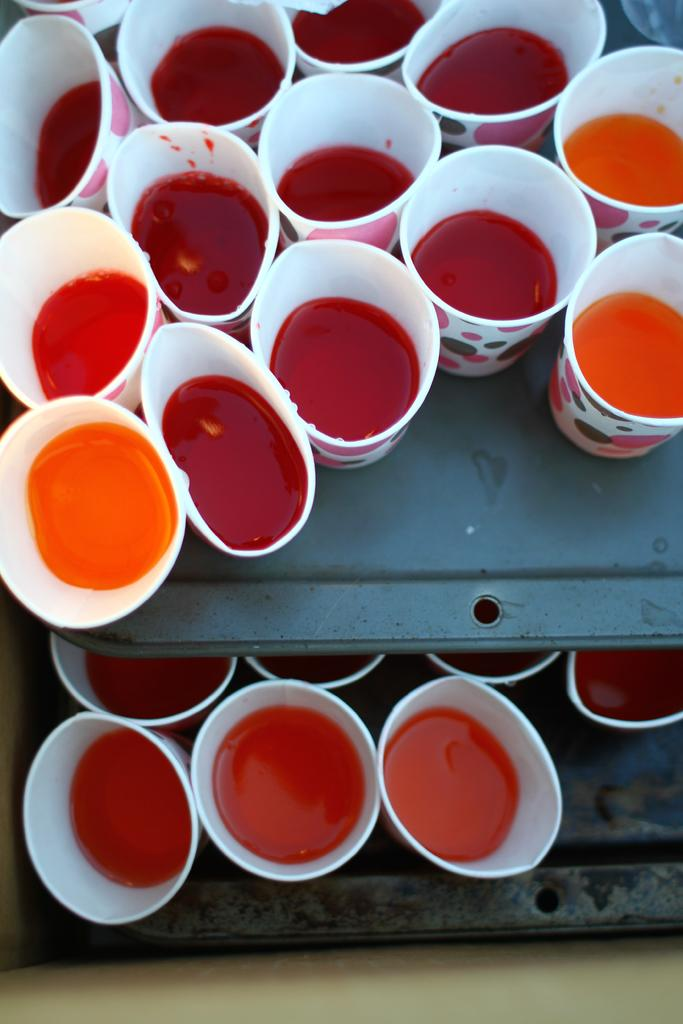What objects are present in the image? There are glasses in the image. Where are the glasses located? The glasses are on metal shelves. Can you tell me how many thumbs are visible in the image? There are no thumbs visible in the image. Does the existence of the glasses in the image prove the existence of the universe? The presence of glasses in the image does not prove the existence of the universe; it only confirms the presence of glasses in the image. 